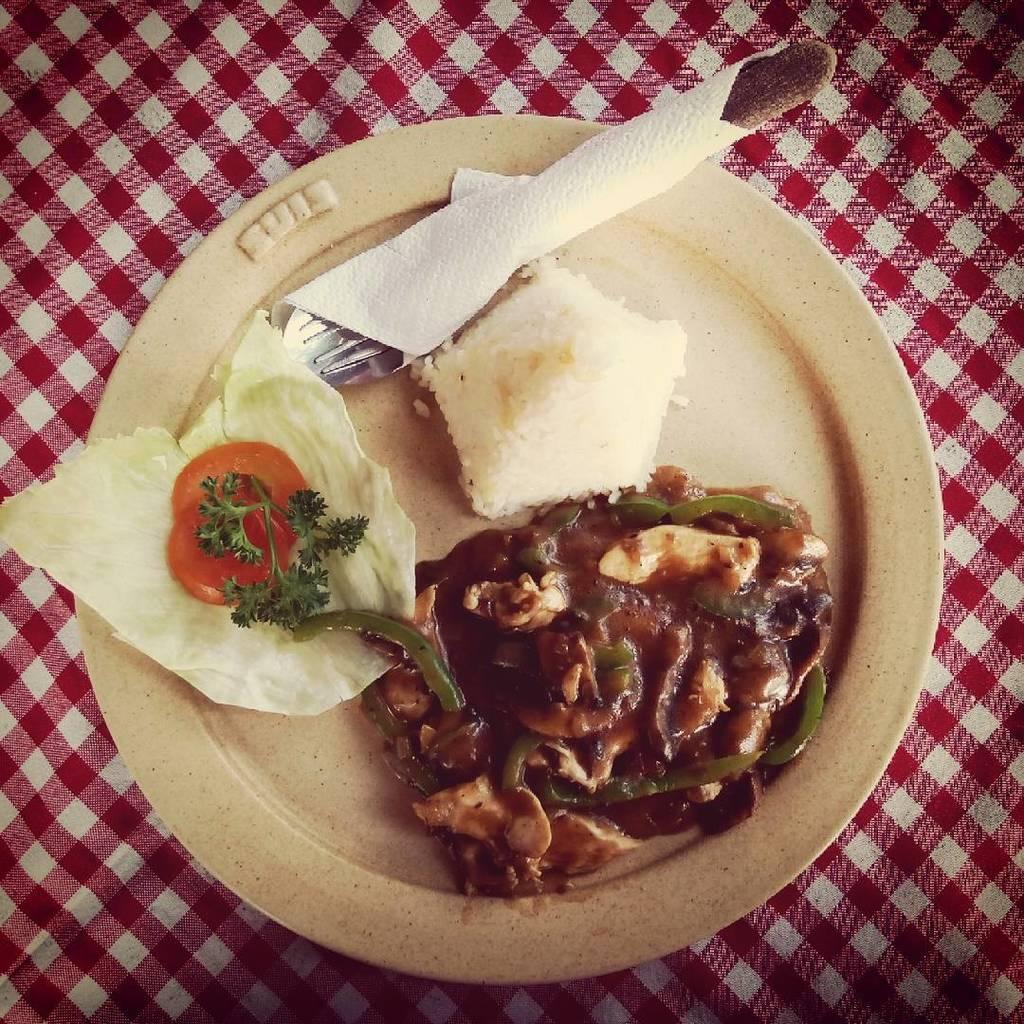Could you give a brief overview of what you see in this image? In this picture there is a plate in the center of the image, which contains food item in it, there is a fork and a tissue on it. 